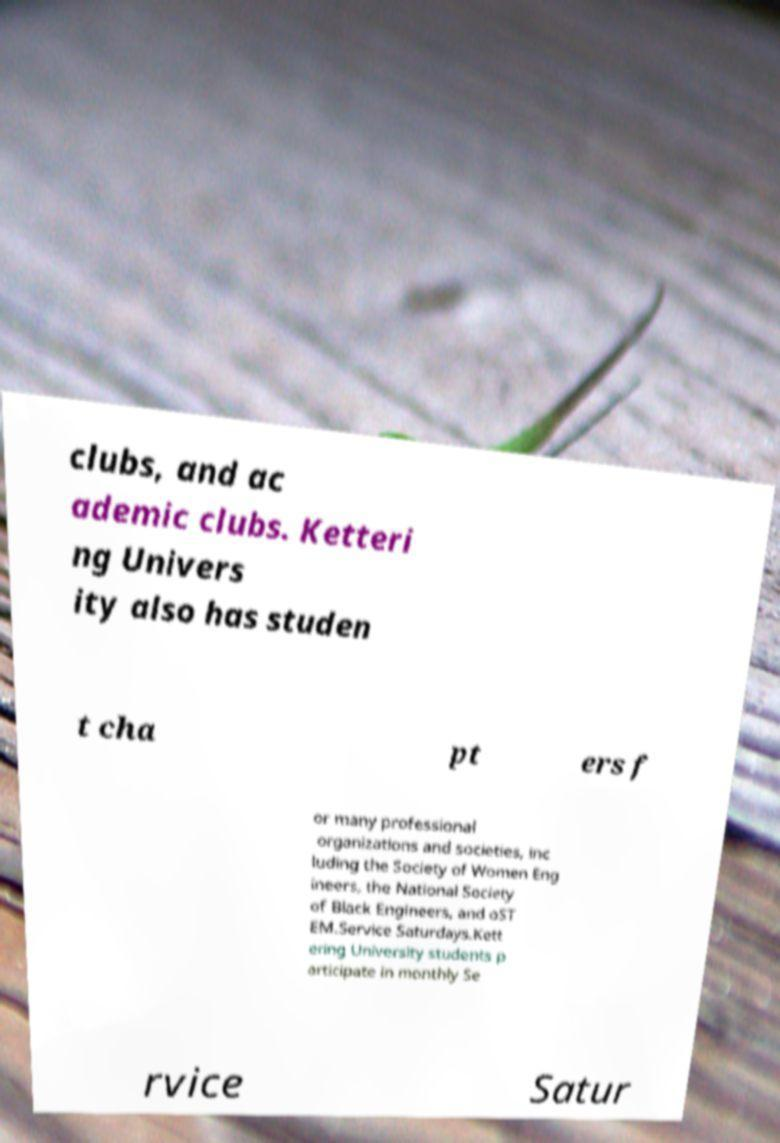Please read and relay the text visible in this image. What does it say? clubs, and ac ademic clubs. Ketteri ng Univers ity also has studen t cha pt ers f or many professional organizations and societies, inc luding the Society of Women Eng ineers, the National Society of Black Engineers, and oST EM.Service Saturdays.Kett ering University students p articipate in monthly Se rvice Satur 